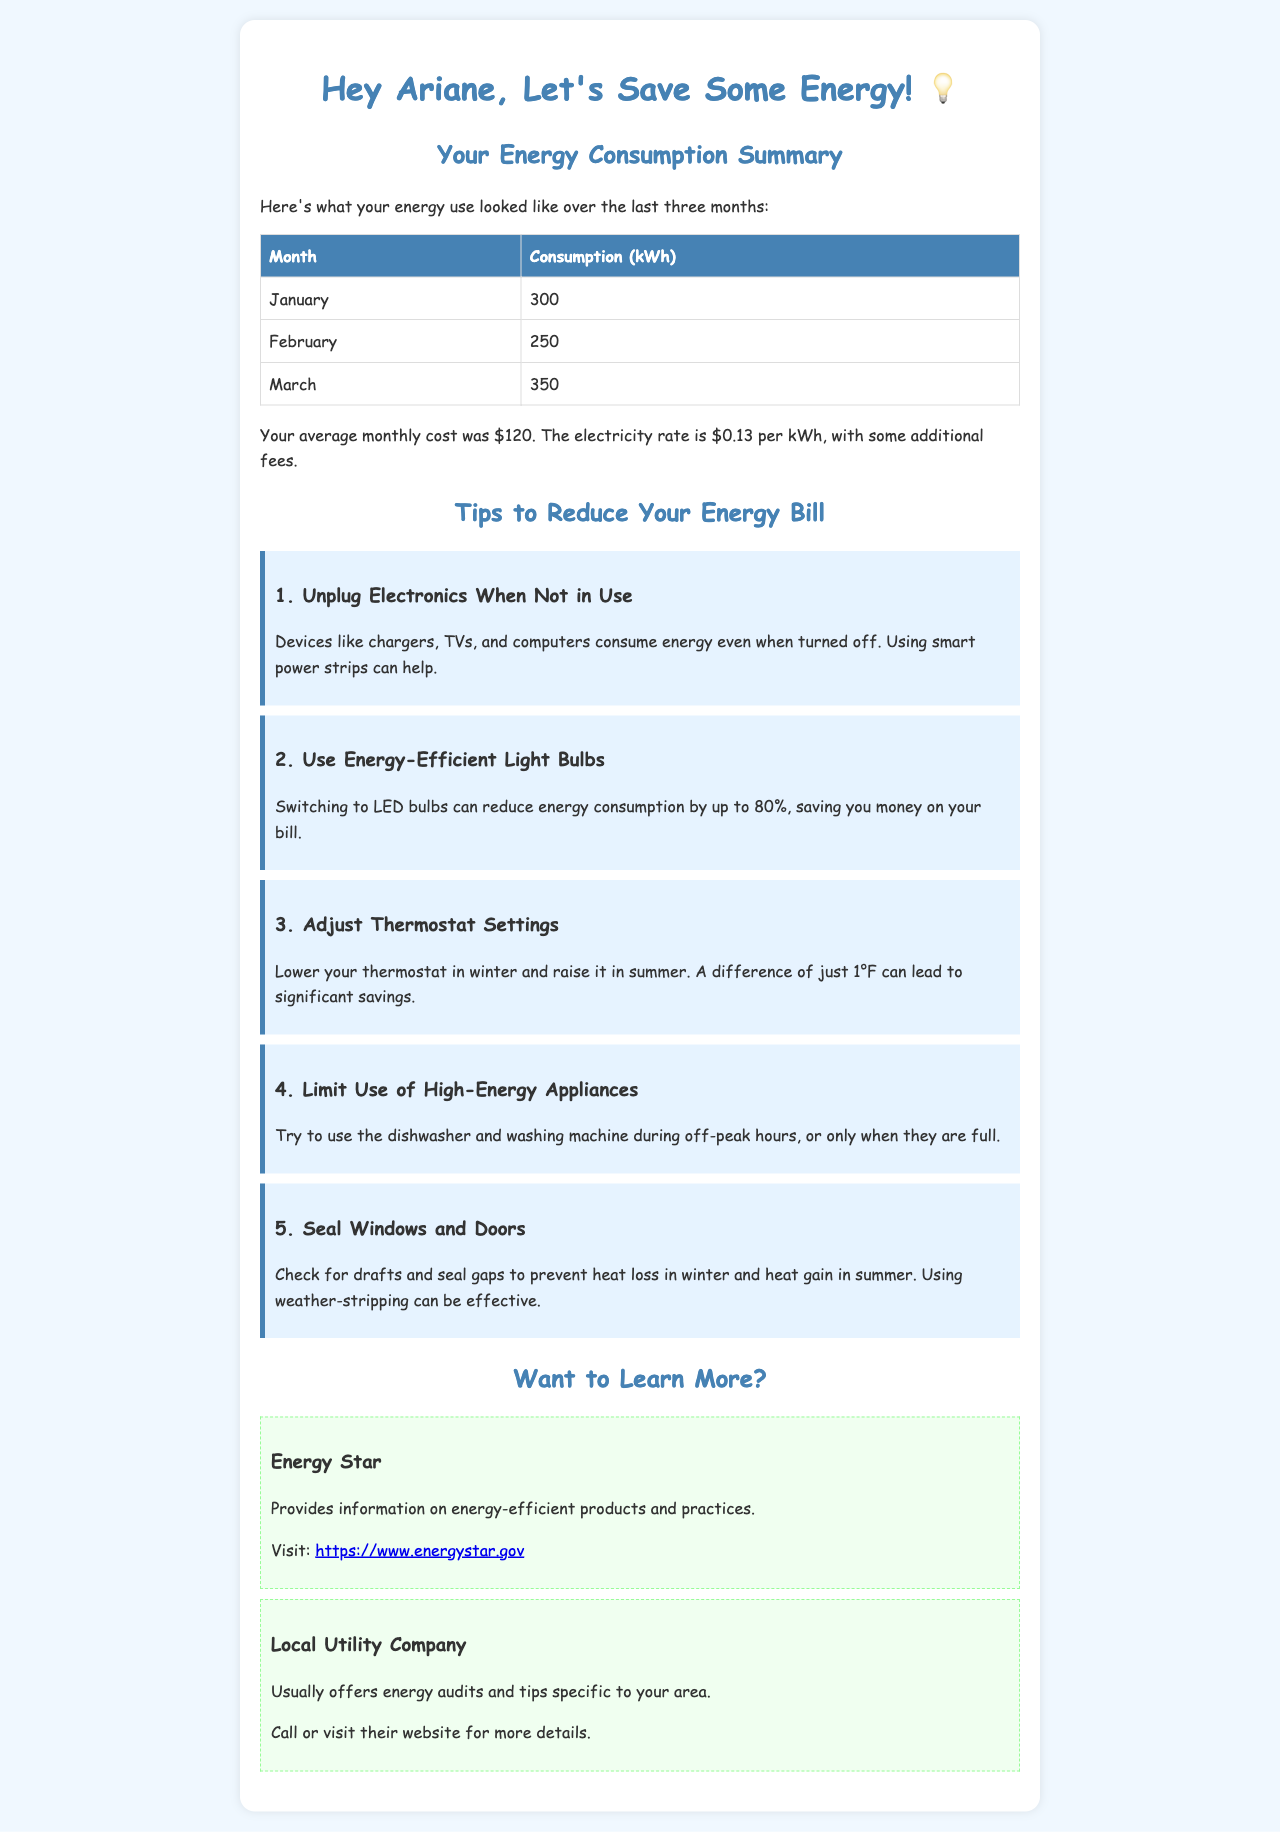What was the energy consumption in January? The energy consumption in January is listed as 300 kWh.
Answer: 300 kWh What is the average monthly cost? The average monthly cost is calculated from the provided consumption and electricity rate. It states that the average monthly cost was $120.
Answer: $120 Which month had the highest energy consumption? The month with the highest energy consumption is identified in the table, which shows March as having 350 kWh.
Answer: March What is one of the tips for reducing energy consumption? The document lists various tips, one being to unplug electronics when not in use.
Answer: Unplug Electronics When Not in Use How much can switching to LED bulbs reduce energy consumption? The document states that switching to LED bulbs can reduce energy consumption by up to 80%.
Answer: 80% Where can you find information on energy-efficient products? The document suggests visiting Energy Star for information on energy-efficient products and practices.
Answer: Energy Star What is suggested to adjust to save energy? The document recommends adjusting thermostat settings for energy savings.
Answer: Adjust Thermostat Settings What is one benefit of sealing windows and doors? Sealing windows and doors prevents heat loss in winter and heat gain in summer.
Answer: Prevents heat loss and heat gain 